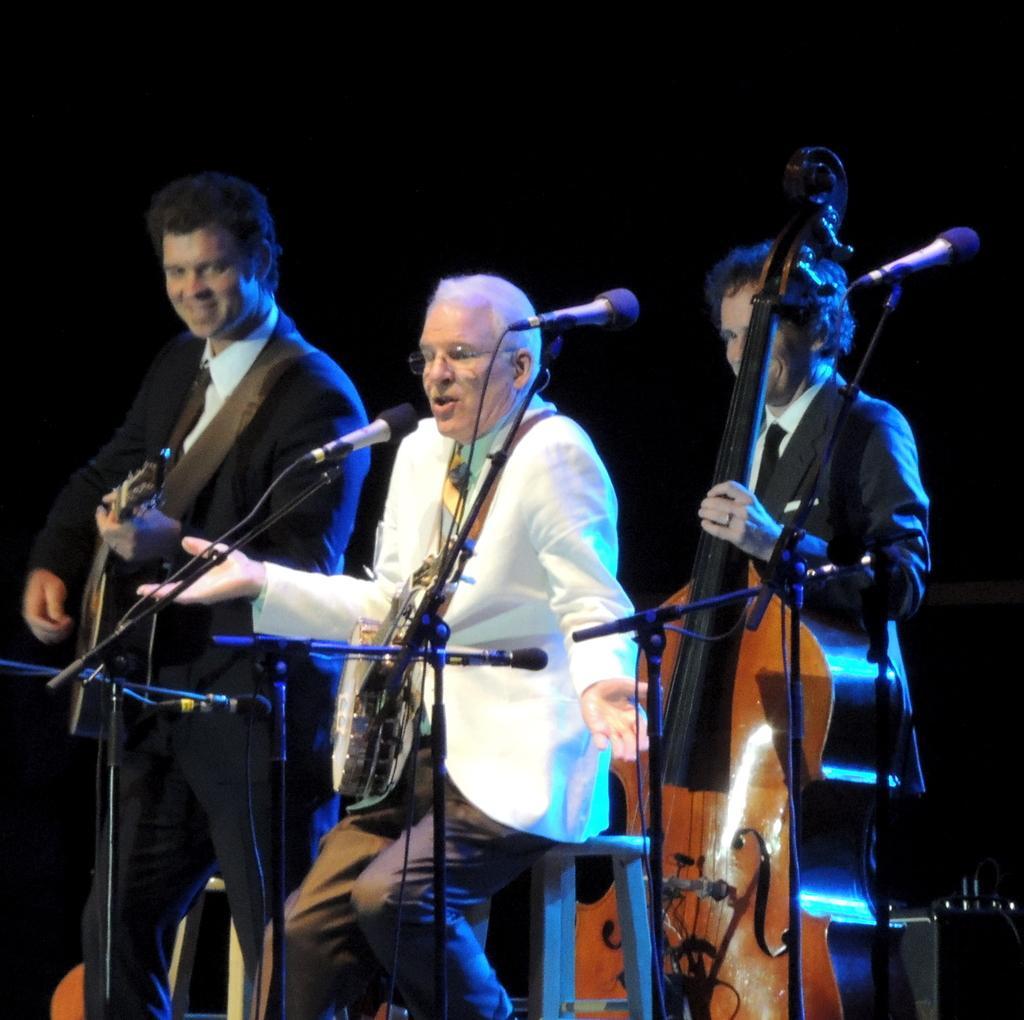Describe this image in one or two sentences. In this picture there are three people on the stage those who are performing the music, the person who is at the left side of the image is playing the guitar and the lady who is at the left side of the image is also playing the guitar and the person who is at the center of the image is singing. 